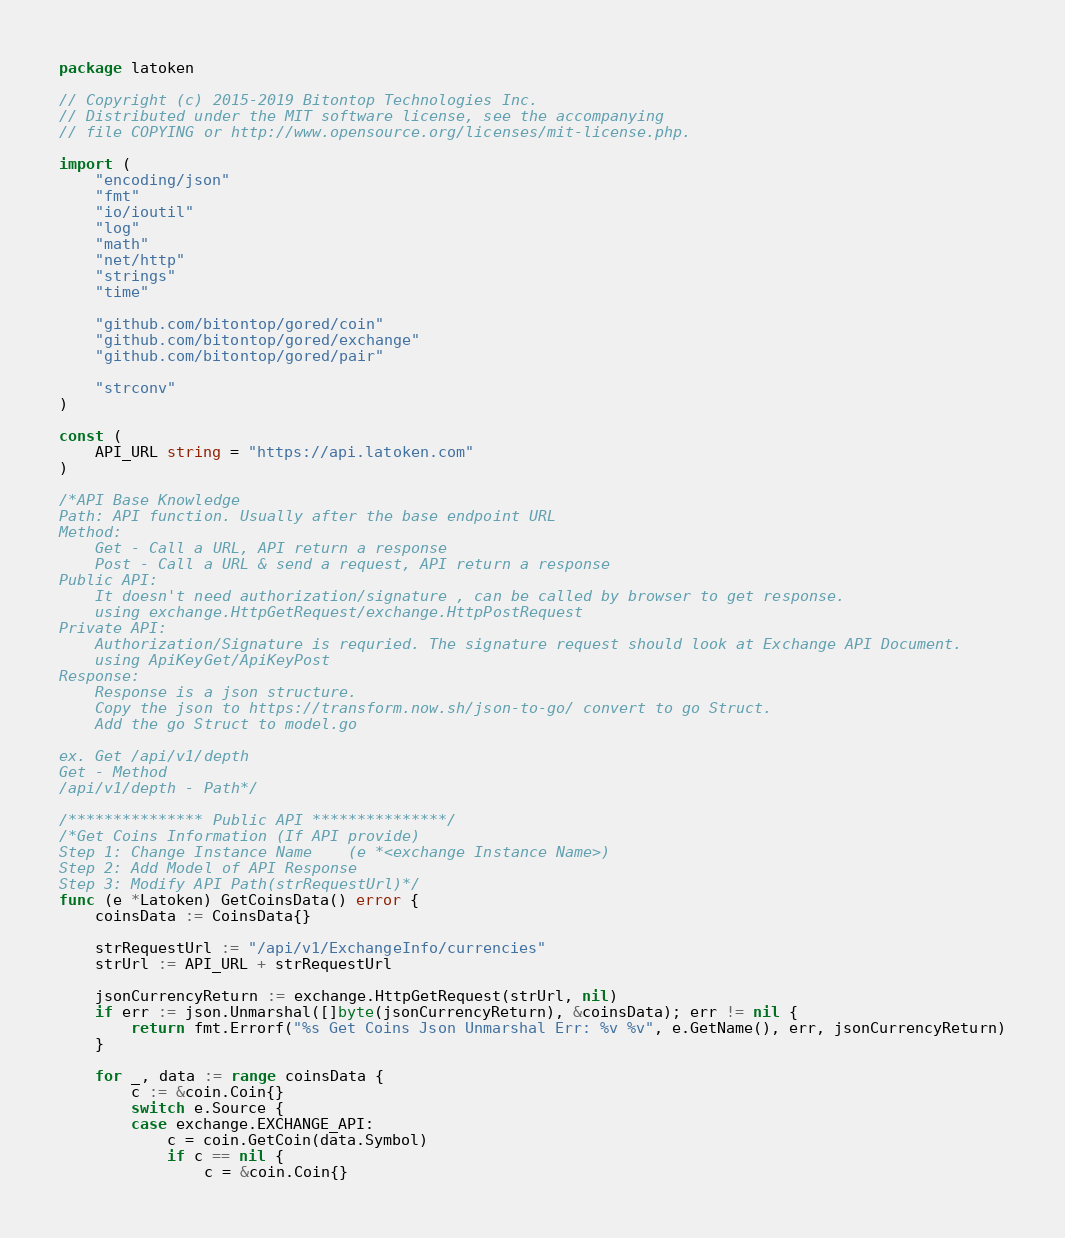<code> <loc_0><loc_0><loc_500><loc_500><_Go_>package latoken

// Copyright (c) 2015-2019 Bitontop Technologies Inc.
// Distributed under the MIT software license, see the accompanying
// file COPYING or http://www.opensource.org/licenses/mit-license.php.

import (
	"encoding/json"
	"fmt"
	"io/ioutil"
	"log"
	"math"
	"net/http"
	"strings"
	"time"

	"github.com/bitontop/gored/coin"
	"github.com/bitontop/gored/exchange"
	"github.com/bitontop/gored/pair"

	"strconv"
)

const (
	API_URL string = "https://api.latoken.com"
)

/*API Base Knowledge
Path: API function. Usually after the base endpoint URL
Method:
	Get - Call a URL, API return a response
	Post - Call a URL & send a request, API return a response
Public API:
	It doesn't need authorization/signature , can be called by browser to get response.
	using exchange.HttpGetRequest/exchange.HttpPostRequest
Private API:
	Authorization/Signature is requried. The signature request should look at Exchange API Document.
	using ApiKeyGet/ApiKeyPost
Response:
	Response is a json structure.
	Copy the json to https://transform.now.sh/json-to-go/ convert to go Struct.
	Add the go Struct to model.go

ex. Get /api/v1/depth
Get - Method
/api/v1/depth - Path*/

/*************** Public API ***************/
/*Get Coins Information (If API provide)
Step 1: Change Instance Name    (e *<exchange Instance Name>)
Step 2: Add Model of API Response
Step 3: Modify API Path(strRequestUrl)*/
func (e *Latoken) GetCoinsData() error {
	coinsData := CoinsData{}

	strRequestUrl := "/api/v1/ExchangeInfo/currencies"
	strUrl := API_URL + strRequestUrl

	jsonCurrencyReturn := exchange.HttpGetRequest(strUrl, nil)
	if err := json.Unmarshal([]byte(jsonCurrencyReturn), &coinsData); err != nil {
		return fmt.Errorf("%s Get Coins Json Unmarshal Err: %v %v", e.GetName(), err, jsonCurrencyReturn)
	}

	for _, data := range coinsData {
		c := &coin.Coin{}
		switch e.Source {
		case exchange.EXCHANGE_API:
			c = coin.GetCoin(data.Symbol)
			if c == nil {
				c = &coin.Coin{}</code> 